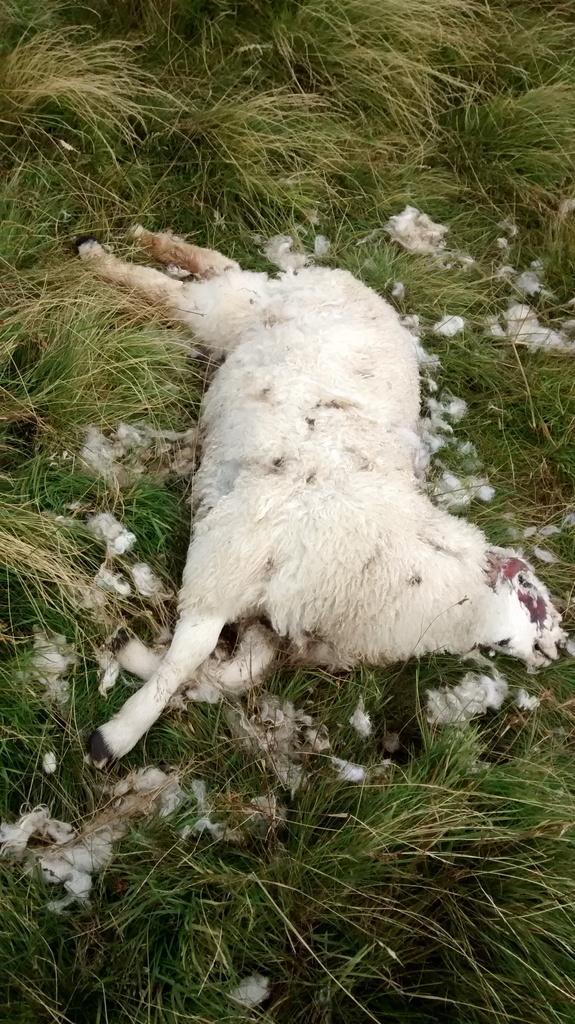What color is the animal in the image? The animal in the image is white. What is the animal doing in the image? The animal is laying on the grass. Where is the animal located in the image? The animal is on the ground. What is the condition of the animal in the image? The animal is dead. What type of vegetation can be seen in the background of the image? There is grass in the background of the image. What type of knowledge can be gained from the animal in the image? There is no knowledge to be gained from the animal in the image, as it is dead. Can you tell me how many cellars are visible in the image? There are no cellars present in the image. 